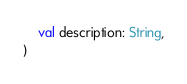<code> <loc_0><loc_0><loc_500><loc_500><_Kotlin_>    val description: String,
)
</code> 